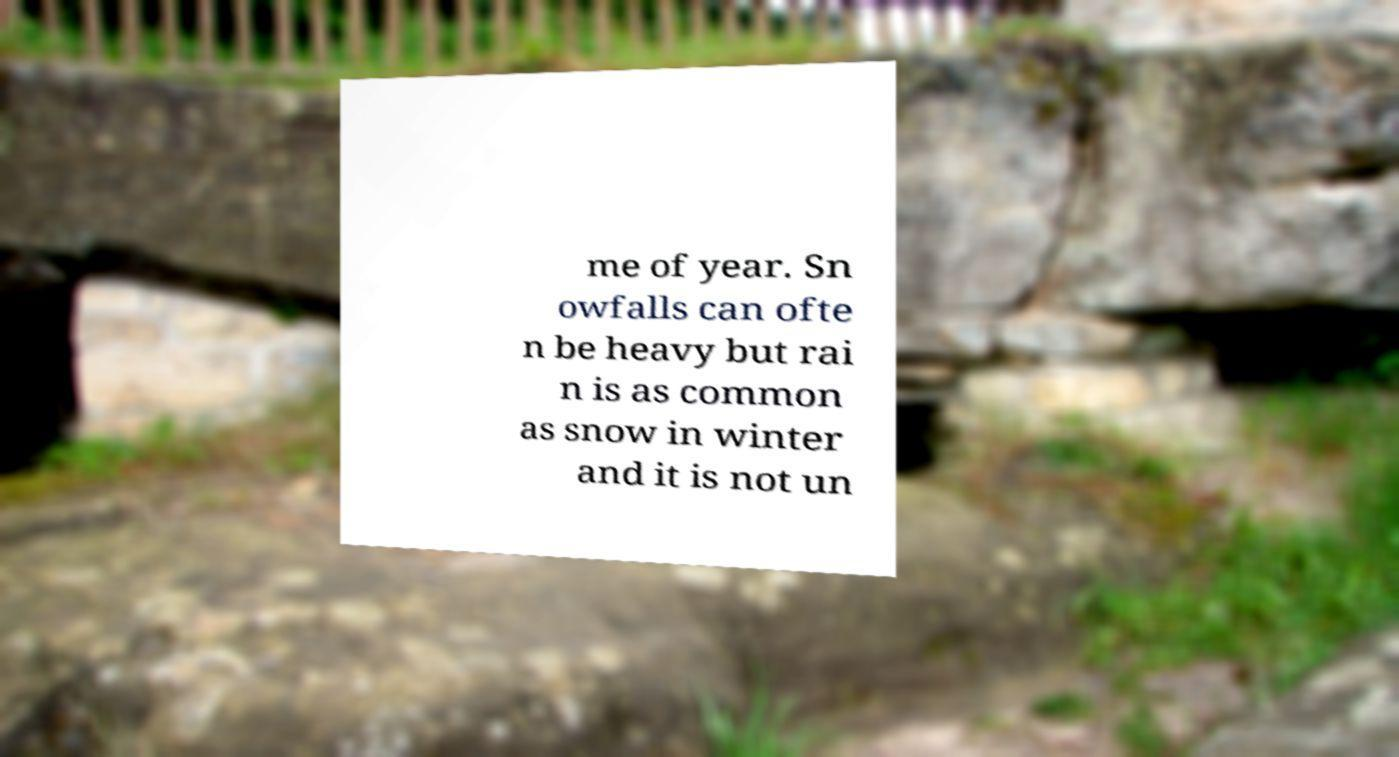For documentation purposes, I need the text within this image transcribed. Could you provide that? me of year. Sn owfalls can ofte n be heavy but rai n is as common as snow in winter and it is not un 